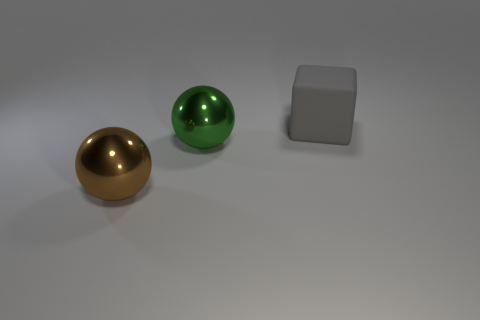Does the large matte thing have the same shape as the shiny object behind the brown ball?
Provide a short and direct response. No. What number of things are shiny spheres that are behind the big brown metallic ball or things in front of the large block?
Offer a very short reply. 2. There is a thing behind the green ball; what is its shape?
Your answer should be compact. Cube. There is a gray matte object that is to the right of the big brown metal thing; does it have the same shape as the big green metallic thing?
Ensure brevity in your answer.  No. What number of things are shiny spheres behind the brown shiny ball or big blue cylinders?
Provide a succinct answer. 1. There is another metal thing that is the same shape as the brown object; what is its color?
Your response must be concise. Green. Is there any other thing that is the same color as the block?
Your response must be concise. No. What is the size of the sphere to the left of the green metallic ball?
Ensure brevity in your answer.  Large. There is a rubber cube; is its color the same as the big object that is in front of the green ball?
Your response must be concise. No. What number of other things are the same material as the green sphere?
Give a very brief answer. 1. 